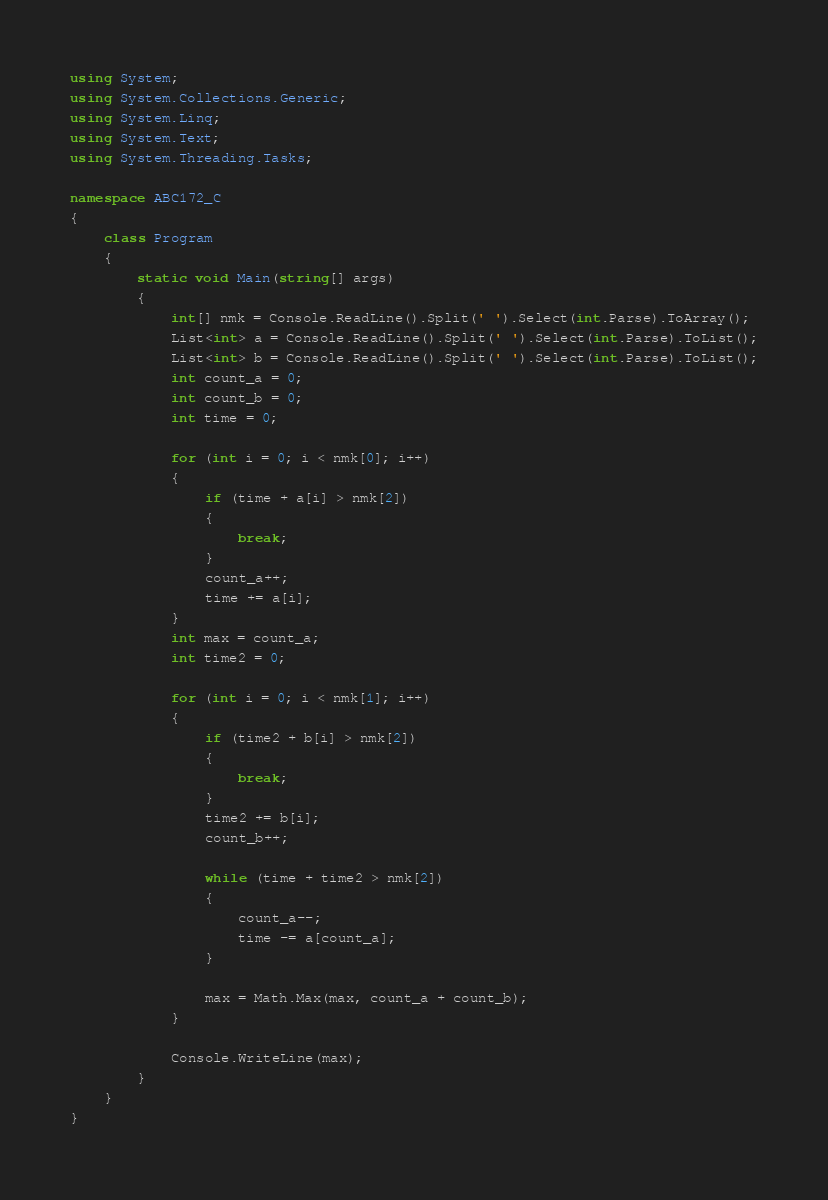Convert code to text. <code><loc_0><loc_0><loc_500><loc_500><_C#_>using System;
using System.Collections.Generic;
using System.Linq;
using System.Text;
using System.Threading.Tasks;

namespace ABC172_C
{
    class Program
    {
        static void Main(string[] args)
        {
            int[] nmk = Console.ReadLine().Split(' ').Select(int.Parse).ToArray();
            List<int> a = Console.ReadLine().Split(' ').Select(int.Parse).ToList();
            List<int> b = Console.ReadLine().Split(' ').Select(int.Parse).ToList();
            int count_a = 0;
            int count_b = 0;
            int time = 0;

            for (int i = 0; i < nmk[0]; i++)
            {
                if (time + a[i] > nmk[2])
                {
                    break;
                }
                count_a++;
                time += a[i];
            }
            int max = count_a;
            int time2 = 0;

            for (int i = 0; i < nmk[1]; i++)
            {
                if (time2 + b[i] > nmk[2])
                {
                    break;
                }
                time2 += b[i];
                count_b++;

                while (time + time2 > nmk[2])
                {
                    count_a--;
                    time -= a[count_a];
                }

                max = Math.Max(max, count_a + count_b);
            }

            Console.WriteLine(max);
        }
    }
}
</code> 